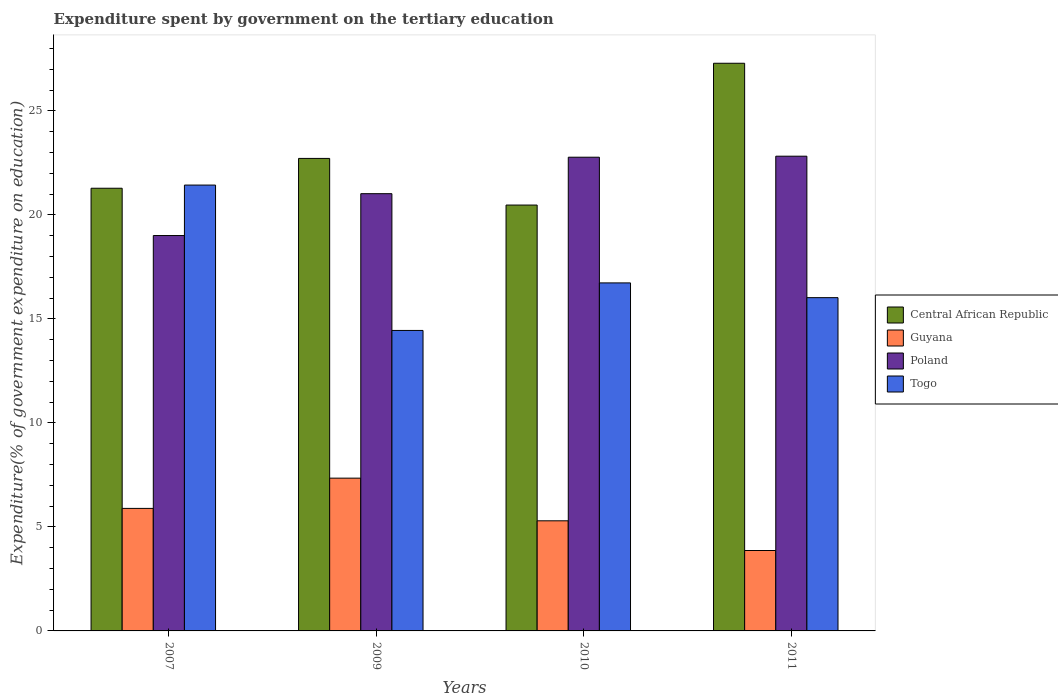Are the number of bars on each tick of the X-axis equal?
Your response must be concise. Yes. What is the label of the 3rd group of bars from the left?
Offer a terse response. 2010. In how many cases, is the number of bars for a given year not equal to the number of legend labels?
Offer a terse response. 0. What is the expenditure spent by government on the tertiary education in Poland in 2007?
Your answer should be compact. 19.01. Across all years, what is the maximum expenditure spent by government on the tertiary education in Guyana?
Your answer should be very brief. 7.34. Across all years, what is the minimum expenditure spent by government on the tertiary education in Poland?
Provide a succinct answer. 19.01. What is the total expenditure spent by government on the tertiary education in Poland in the graph?
Make the answer very short. 85.63. What is the difference between the expenditure spent by government on the tertiary education in Central African Republic in 2007 and that in 2011?
Your response must be concise. -6.01. What is the difference between the expenditure spent by government on the tertiary education in Guyana in 2010 and the expenditure spent by government on the tertiary education in Poland in 2009?
Your answer should be compact. -15.73. What is the average expenditure spent by government on the tertiary education in Togo per year?
Give a very brief answer. 17.16. In the year 2007, what is the difference between the expenditure spent by government on the tertiary education in Poland and expenditure spent by government on the tertiary education in Togo?
Give a very brief answer. -2.43. What is the ratio of the expenditure spent by government on the tertiary education in Poland in 2010 to that in 2011?
Make the answer very short. 1. Is the expenditure spent by government on the tertiary education in Central African Republic in 2009 less than that in 2010?
Provide a succinct answer. No. What is the difference between the highest and the second highest expenditure spent by government on the tertiary education in Poland?
Make the answer very short. 0.05. What is the difference between the highest and the lowest expenditure spent by government on the tertiary education in Togo?
Ensure brevity in your answer.  6.99. What does the 4th bar from the left in 2011 represents?
Keep it short and to the point. Togo. What does the 3rd bar from the right in 2011 represents?
Provide a succinct answer. Guyana. Is it the case that in every year, the sum of the expenditure spent by government on the tertiary education in Togo and expenditure spent by government on the tertiary education in Poland is greater than the expenditure spent by government on the tertiary education in Guyana?
Provide a succinct answer. Yes. How many bars are there?
Offer a terse response. 16. How many years are there in the graph?
Your response must be concise. 4. Are the values on the major ticks of Y-axis written in scientific E-notation?
Ensure brevity in your answer.  No. Does the graph contain any zero values?
Your response must be concise. No. How many legend labels are there?
Provide a short and direct response. 4. How are the legend labels stacked?
Offer a very short reply. Vertical. What is the title of the graph?
Keep it short and to the point. Expenditure spent by government on the tertiary education. What is the label or title of the Y-axis?
Provide a short and direct response. Expenditure(% of government expenditure on education). What is the Expenditure(% of government expenditure on education) of Central African Republic in 2007?
Provide a succinct answer. 21.28. What is the Expenditure(% of government expenditure on education) of Guyana in 2007?
Your response must be concise. 5.89. What is the Expenditure(% of government expenditure on education) of Poland in 2007?
Keep it short and to the point. 19.01. What is the Expenditure(% of government expenditure on education) in Togo in 2007?
Ensure brevity in your answer.  21.43. What is the Expenditure(% of government expenditure on education) in Central African Republic in 2009?
Keep it short and to the point. 22.72. What is the Expenditure(% of government expenditure on education) in Guyana in 2009?
Your answer should be very brief. 7.34. What is the Expenditure(% of government expenditure on education) of Poland in 2009?
Give a very brief answer. 21.02. What is the Expenditure(% of government expenditure on education) of Togo in 2009?
Provide a succinct answer. 14.45. What is the Expenditure(% of government expenditure on education) in Central African Republic in 2010?
Offer a very short reply. 20.47. What is the Expenditure(% of government expenditure on education) in Guyana in 2010?
Provide a short and direct response. 5.29. What is the Expenditure(% of government expenditure on education) in Poland in 2010?
Your answer should be compact. 22.77. What is the Expenditure(% of government expenditure on education) of Togo in 2010?
Offer a very short reply. 16.73. What is the Expenditure(% of government expenditure on education) of Central African Republic in 2011?
Your response must be concise. 27.29. What is the Expenditure(% of government expenditure on education) in Guyana in 2011?
Ensure brevity in your answer.  3.87. What is the Expenditure(% of government expenditure on education) of Poland in 2011?
Your response must be concise. 22.82. What is the Expenditure(% of government expenditure on education) of Togo in 2011?
Offer a terse response. 16.02. Across all years, what is the maximum Expenditure(% of government expenditure on education) of Central African Republic?
Make the answer very short. 27.29. Across all years, what is the maximum Expenditure(% of government expenditure on education) of Guyana?
Offer a very short reply. 7.34. Across all years, what is the maximum Expenditure(% of government expenditure on education) in Poland?
Make the answer very short. 22.82. Across all years, what is the maximum Expenditure(% of government expenditure on education) of Togo?
Provide a short and direct response. 21.43. Across all years, what is the minimum Expenditure(% of government expenditure on education) of Central African Republic?
Your response must be concise. 20.47. Across all years, what is the minimum Expenditure(% of government expenditure on education) of Guyana?
Ensure brevity in your answer.  3.87. Across all years, what is the minimum Expenditure(% of government expenditure on education) of Poland?
Your answer should be very brief. 19.01. Across all years, what is the minimum Expenditure(% of government expenditure on education) in Togo?
Give a very brief answer. 14.45. What is the total Expenditure(% of government expenditure on education) of Central African Republic in the graph?
Make the answer very short. 91.76. What is the total Expenditure(% of government expenditure on education) in Guyana in the graph?
Ensure brevity in your answer.  22.39. What is the total Expenditure(% of government expenditure on education) of Poland in the graph?
Offer a very short reply. 85.63. What is the total Expenditure(% of government expenditure on education) of Togo in the graph?
Keep it short and to the point. 68.63. What is the difference between the Expenditure(% of government expenditure on education) in Central African Republic in 2007 and that in 2009?
Provide a short and direct response. -1.43. What is the difference between the Expenditure(% of government expenditure on education) of Guyana in 2007 and that in 2009?
Offer a very short reply. -1.45. What is the difference between the Expenditure(% of government expenditure on education) of Poland in 2007 and that in 2009?
Offer a very short reply. -2.01. What is the difference between the Expenditure(% of government expenditure on education) in Togo in 2007 and that in 2009?
Provide a succinct answer. 6.99. What is the difference between the Expenditure(% of government expenditure on education) of Central African Republic in 2007 and that in 2010?
Provide a short and direct response. 0.81. What is the difference between the Expenditure(% of government expenditure on education) of Guyana in 2007 and that in 2010?
Your response must be concise. 0.6. What is the difference between the Expenditure(% of government expenditure on education) in Poland in 2007 and that in 2010?
Give a very brief answer. -3.77. What is the difference between the Expenditure(% of government expenditure on education) of Togo in 2007 and that in 2010?
Make the answer very short. 4.7. What is the difference between the Expenditure(% of government expenditure on education) in Central African Republic in 2007 and that in 2011?
Your answer should be compact. -6.01. What is the difference between the Expenditure(% of government expenditure on education) in Guyana in 2007 and that in 2011?
Offer a very short reply. 2.02. What is the difference between the Expenditure(% of government expenditure on education) of Poland in 2007 and that in 2011?
Give a very brief answer. -3.81. What is the difference between the Expenditure(% of government expenditure on education) of Togo in 2007 and that in 2011?
Offer a terse response. 5.41. What is the difference between the Expenditure(% of government expenditure on education) of Central African Republic in 2009 and that in 2010?
Keep it short and to the point. 2.24. What is the difference between the Expenditure(% of government expenditure on education) in Guyana in 2009 and that in 2010?
Provide a short and direct response. 2.05. What is the difference between the Expenditure(% of government expenditure on education) in Poland in 2009 and that in 2010?
Keep it short and to the point. -1.75. What is the difference between the Expenditure(% of government expenditure on education) in Togo in 2009 and that in 2010?
Ensure brevity in your answer.  -2.29. What is the difference between the Expenditure(% of government expenditure on education) of Central African Republic in 2009 and that in 2011?
Keep it short and to the point. -4.58. What is the difference between the Expenditure(% of government expenditure on education) in Guyana in 2009 and that in 2011?
Make the answer very short. 3.48. What is the difference between the Expenditure(% of government expenditure on education) in Poland in 2009 and that in 2011?
Offer a terse response. -1.8. What is the difference between the Expenditure(% of government expenditure on education) of Togo in 2009 and that in 2011?
Ensure brevity in your answer.  -1.58. What is the difference between the Expenditure(% of government expenditure on education) in Central African Republic in 2010 and that in 2011?
Provide a short and direct response. -6.82. What is the difference between the Expenditure(% of government expenditure on education) in Guyana in 2010 and that in 2011?
Give a very brief answer. 1.43. What is the difference between the Expenditure(% of government expenditure on education) of Poland in 2010 and that in 2011?
Ensure brevity in your answer.  -0.05. What is the difference between the Expenditure(% of government expenditure on education) in Togo in 2010 and that in 2011?
Provide a short and direct response. 0.71. What is the difference between the Expenditure(% of government expenditure on education) of Central African Republic in 2007 and the Expenditure(% of government expenditure on education) of Guyana in 2009?
Make the answer very short. 13.94. What is the difference between the Expenditure(% of government expenditure on education) of Central African Republic in 2007 and the Expenditure(% of government expenditure on education) of Poland in 2009?
Your answer should be compact. 0.26. What is the difference between the Expenditure(% of government expenditure on education) in Central African Republic in 2007 and the Expenditure(% of government expenditure on education) in Togo in 2009?
Ensure brevity in your answer.  6.84. What is the difference between the Expenditure(% of government expenditure on education) in Guyana in 2007 and the Expenditure(% of government expenditure on education) in Poland in 2009?
Your response must be concise. -15.13. What is the difference between the Expenditure(% of government expenditure on education) of Guyana in 2007 and the Expenditure(% of government expenditure on education) of Togo in 2009?
Provide a succinct answer. -8.56. What is the difference between the Expenditure(% of government expenditure on education) of Poland in 2007 and the Expenditure(% of government expenditure on education) of Togo in 2009?
Offer a very short reply. 4.56. What is the difference between the Expenditure(% of government expenditure on education) in Central African Republic in 2007 and the Expenditure(% of government expenditure on education) in Guyana in 2010?
Make the answer very short. 15.99. What is the difference between the Expenditure(% of government expenditure on education) of Central African Republic in 2007 and the Expenditure(% of government expenditure on education) of Poland in 2010?
Keep it short and to the point. -1.49. What is the difference between the Expenditure(% of government expenditure on education) of Central African Republic in 2007 and the Expenditure(% of government expenditure on education) of Togo in 2010?
Make the answer very short. 4.55. What is the difference between the Expenditure(% of government expenditure on education) of Guyana in 2007 and the Expenditure(% of government expenditure on education) of Poland in 2010?
Provide a succinct answer. -16.88. What is the difference between the Expenditure(% of government expenditure on education) in Guyana in 2007 and the Expenditure(% of government expenditure on education) in Togo in 2010?
Offer a terse response. -10.84. What is the difference between the Expenditure(% of government expenditure on education) of Poland in 2007 and the Expenditure(% of government expenditure on education) of Togo in 2010?
Offer a very short reply. 2.28. What is the difference between the Expenditure(% of government expenditure on education) in Central African Republic in 2007 and the Expenditure(% of government expenditure on education) in Guyana in 2011?
Keep it short and to the point. 17.42. What is the difference between the Expenditure(% of government expenditure on education) in Central African Republic in 2007 and the Expenditure(% of government expenditure on education) in Poland in 2011?
Provide a succinct answer. -1.54. What is the difference between the Expenditure(% of government expenditure on education) of Central African Republic in 2007 and the Expenditure(% of government expenditure on education) of Togo in 2011?
Your answer should be compact. 5.26. What is the difference between the Expenditure(% of government expenditure on education) of Guyana in 2007 and the Expenditure(% of government expenditure on education) of Poland in 2011?
Provide a short and direct response. -16.93. What is the difference between the Expenditure(% of government expenditure on education) of Guyana in 2007 and the Expenditure(% of government expenditure on education) of Togo in 2011?
Keep it short and to the point. -10.13. What is the difference between the Expenditure(% of government expenditure on education) of Poland in 2007 and the Expenditure(% of government expenditure on education) of Togo in 2011?
Keep it short and to the point. 2.99. What is the difference between the Expenditure(% of government expenditure on education) in Central African Republic in 2009 and the Expenditure(% of government expenditure on education) in Guyana in 2010?
Your answer should be very brief. 17.42. What is the difference between the Expenditure(% of government expenditure on education) in Central African Republic in 2009 and the Expenditure(% of government expenditure on education) in Poland in 2010?
Make the answer very short. -0.06. What is the difference between the Expenditure(% of government expenditure on education) in Central African Republic in 2009 and the Expenditure(% of government expenditure on education) in Togo in 2010?
Make the answer very short. 5.98. What is the difference between the Expenditure(% of government expenditure on education) of Guyana in 2009 and the Expenditure(% of government expenditure on education) of Poland in 2010?
Provide a succinct answer. -15.43. What is the difference between the Expenditure(% of government expenditure on education) of Guyana in 2009 and the Expenditure(% of government expenditure on education) of Togo in 2010?
Offer a very short reply. -9.39. What is the difference between the Expenditure(% of government expenditure on education) in Poland in 2009 and the Expenditure(% of government expenditure on education) in Togo in 2010?
Provide a succinct answer. 4.29. What is the difference between the Expenditure(% of government expenditure on education) in Central African Republic in 2009 and the Expenditure(% of government expenditure on education) in Guyana in 2011?
Give a very brief answer. 18.85. What is the difference between the Expenditure(% of government expenditure on education) in Central African Republic in 2009 and the Expenditure(% of government expenditure on education) in Poland in 2011?
Keep it short and to the point. -0.11. What is the difference between the Expenditure(% of government expenditure on education) of Central African Republic in 2009 and the Expenditure(% of government expenditure on education) of Togo in 2011?
Ensure brevity in your answer.  6.69. What is the difference between the Expenditure(% of government expenditure on education) in Guyana in 2009 and the Expenditure(% of government expenditure on education) in Poland in 2011?
Offer a terse response. -15.48. What is the difference between the Expenditure(% of government expenditure on education) of Guyana in 2009 and the Expenditure(% of government expenditure on education) of Togo in 2011?
Your response must be concise. -8.68. What is the difference between the Expenditure(% of government expenditure on education) of Poland in 2009 and the Expenditure(% of government expenditure on education) of Togo in 2011?
Ensure brevity in your answer.  5. What is the difference between the Expenditure(% of government expenditure on education) in Central African Republic in 2010 and the Expenditure(% of government expenditure on education) in Guyana in 2011?
Give a very brief answer. 16.61. What is the difference between the Expenditure(% of government expenditure on education) of Central African Republic in 2010 and the Expenditure(% of government expenditure on education) of Poland in 2011?
Keep it short and to the point. -2.35. What is the difference between the Expenditure(% of government expenditure on education) of Central African Republic in 2010 and the Expenditure(% of government expenditure on education) of Togo in 2011?
Give a very brief answer. 4.45. What is the difference between the Expenditure(% of government expenditure on education) in Guyana in 2010 and the Expenditure(% of government expenditure on education) in Poland in 2011?
Ensure brevity in your answer.  -17.53. What is the difference between the Expenditure(% of government expenditure on education) in Guyana in 2010 and the Expenditure(% of government expenditure on education) in Togo in 2011?
Provide a short and direct response. -10.73. What is the difference between the Expenditure(% of government expenditure on education) in Poland in 2010 and the Expenditure(% of government expenditure on education) in Togo in 2011?
Keep it short and to the point. 6.75. What is the average Expenditure(% of government expenditure on education) of Central African Republic per year?
Your answer should be very brief. 22.94. What is the average Expenditure(% of government expenditure on education) in Guyana per year?
Your response must be concise. 5.6. What is the average Expenditure(% of government expenditure on education) of Poland per year?
Your answer should be very brief. 21.41. What is the average Expenditure(% of government expenditure on education) in Togo per year?
Your answer should be very brief. 17.16. In the year 2007, what is the difference between the Expenditure(% of government expenditure on education) of Central African Republic and Expenditure(% of government expenditure on education) of Guyana?
Offer a very short reply. 15.39. In the year 2007, what is the difference between the Expenditure(% of government expenditure on education) in Central African Republic and Expenditure(% of government expenditure on education) in Poland?
Offer a terse response. 2.27. In the year 2007, what is the difference between the Expenditure(% of government expenditure on education) in Central African Republic and Expenditure(% of government expenditure on education) in Togo?
Your response must be concise. -0.15. In the year 2007, what is the difference between the Expenditure(% of government expenditure on education) in Guyana and Expenditure(% of government expenditure on education) in Poland?
Provide a short and direct response. -13.12. In the year 2007, what is the difference between the Expenditure(% of government expenditure on education) in Guyana and Expenditure(% of government expenditure on education) in Togo?
Provide a short and direct response. -15.54. In the year 2007, what is the difference between the Expenditure(% of government expenditure on education) in Poland and Expenditure(% of government expenditure on education) in Togo?
Your answer should be very brief. -2.43. In the year 2009, what is the difference between the Expenditure(% of government expenditure on education) in Central African Republic and Expenditure(% of government expenditure on education) in Guyana?
Give a very brief answer. 15.37. In the year 2009, what is the difference between the Expenditure(% of government expenditure on education) in Central African Republic and Expenditure(% of government expenditure on education) in Poland?
Offer a very short reply. 1.7. In the year 2009, what is the difference between the Expenditure(% of government expenditure on education) of Central African Republic and Expenditure(% of government expenditure on education) of Togo?
Provide a short and direct response. 8.27. In the year 2009, what is the difference between the Expenditure(% of government expenditure on education) in Guyana and Expenditure(% of government expenditure on education) in Poland?
Provide a succinct answer. -13.68. In the year 2009, what is the difference between the Expenditure(% of government expenditure on education) of Guyana and Expenditure(% of government expenditure on education) of Togo?
Ensure brevity in your answer.  -7.1. In the year 2009, what is the difference between the Expenditure(% of government expenditure on education) in Poland and Expenditure(% of government expenditure on education) in Togo?
Keep it short and to the point. 6.57. In the year 2010, what is the difference between the Expenditure(% of government expenditure on education) of Central African Republic and Expenditure(% of government expenditure on education) of Guyana?
Offer a very short reply. 15.18. In the year 2010, what is the difference between the Expenditure(% of government expenditure on education) in Central African Republic and Expenditure(% of government expenditure on education) in Poland?
Your answer should be very brief. -2.3. In the year 2010, what is the difference between the Expenditure(% of government expenditure on education) of Central African Republic and Expenditure(% of government expenditure on education) of Togo?
Your response must be concise. 3.74. In the year 2010, what is the difference between the Expenditure(% of government expenditure on education) in Guyana and Expenditure(% of government expenditure on education) in Poland?
Provide a succinct answer. -17.48. In the year 2010, what is the difference between the Expenditure(% of government expenditure on education) in Guyana and Expenditure(% of government expenditure on education) in Togo?
Offer a very short reply. -11.44. In the year 2010, what is the difference between the Expenditure(% of government expenditure on education) in Poland and Expenditure(% of government expenditure on education) in Togo?
Offer a terse response. 6.04. In the year 2011, what is the difference between the Expenditure(% of government expenditure on education) of Central African Republic and Expenditure(% of government expenditure on education) of Guyana?
Keep it short and to the point. 23.43. In the year 2011, what is the difference between the Expenditure(% of government expenditure on education) of Central African Republic and Expenditure(% of government expenditure on education) of Poland?
Your answer should be very brief. 4.47. In the year 2011, what is the difference between the Expenditure(% of government expenditure on education) of Central African Republic and Expenditure(% of government expenditure on education) of Togo?
Your answer should be very brief. 11.27. In the year 2011, what is the difference between the Expenditure(% of government expenditure on education) of Guyana and Expenditure(% of government expenditure on education) of Poland?
Make the answer very short. -18.96. In the year 2011, what is the difference between the Expenditure(% of government expenditure on education) in Guyana and Expenditure(% of government expenditure on education) in Togo?
Your response must be concise. -12.16. In the year 2011, what is the difference between the Expenditure(% of government expenditure on education) of Poland and Expenditure(% of government expenditure on education) of Togo?
Provide a short and direct response. 6.8. What is the ratio of the Expenditure(% of government expenditure on education) of Central African Republic in 2007 to that in 2009?
Offer a terse response. 0.94. What is the ratio of the Expenditure(% of government expenditure on education) of Guyana in 2007 to that in 2009?
Your answer should be compact. 0.8. What is the ratio of the Expenditure(% of government expenditure on education) in Poland in 2007 to that in 2009?
Make the answer very short. 0.9. What is the ratio of the Expenditure(% of government expenditure on education) of Togo in 2007 to that in 2009?
Offer a very short reply. 1.48. What is the ratio of the Expenditure(% of government expenditure on education) in Central African Republic in 2007 to that in 2010?
Provide a succinct answer. 1.04. What is the ratio of the Expenditure(% of government expenditure on education) of Guyana in 2007 to that in 2010?
Provide a short and direct response. 1.11. What is the ratio of the Expenditure(% of government expenditure on education) in Poland in 2007 to that in 2010?
Offer a terse response. 0.83. What is the ratio of the Expenditure(% of government expenditure on education) of Togo in 2007 to that in 2010?
Provide a succinct answer. 1.28. What is the ratio of the Expenditure(% of government expenditure on education) of Central African Republic in 2007 to that in 2011?
Make the answer very short. 0.78. What is the ratio of the Expenditure(% of government expenditure on education) in Guyana in 2007 to that in 2011?
Ensure brevity in your answer.  1.52. What is the ratio of the Expenditure(% of government expenditure on education) in Poland in 2007 to that in 2011?
Offer a terse response. 0.83. What is the ratio of the Expenditure(% of government expenditure on education) in Togo in 2007 to that in 2011?
Your answer should be very brief. 1.34. What is the ratio of the Expenditure(% of government expenditure on education) in Central African Republic in 2009 to that in 2010?
Give a very brief answer. 1.11. What is the ratio of the Expenditure(% of government expenditure on education) of Guyana in 2009 to that in 2010?
Ensure brevity in your answer.  1.39. What is the ratio of the Expenditure(% of government expenditure on education) in Poland in 2009 to that in 2010?
Provide a short and direct response. 0.92. What is the ratio of the Expenditure(% of government expenditure on education) of Togo in 2009 to that in 2010?
Ensure brevity in your answer.  0.86. What is the ratio of the Expenditure(% of government expenditure on education) in Central African Republic in 2009 to that in 2011?
Offer a terse response. 0.83. What is the ratio of the Expenditure(% of government expenditure on education) in Guyana in 2009 to that in 2011?
Offer a terse response. 1.9. What is the ratio of the Expenditure(% of government expenditure on education) in Poland in 2009 to that in 2011?
Ensure brevity in your answer.  0.92. What is the ratio of the Expenditure(% of government expenditure on education) in Togo in 2009 to that in 2011?
Your response must be concise. 0.9. What is the ratio of the Expenditure(% of government expenditure on education) in Central African Republic in 2010 to that in 2011?
Make the answer very short. 0.75. What is the ratio of the Expenditure(% of government expenditure on education) of Guyana in 2010 to that in 2011?
Your answer should be compact. 1.37. What is the ratio of the Expenditure(% of government expenditure on education) in Togo in 2010 to that in 2011?
Offer a terse response. 1.04. What is the difference between the highest and the second highest Expenditure(% of government expenditure on education) in Central African Republic?
Keep it short and to the point. 4.58. What is the difference between the highest and the second highest Expenditure(% of government expenditure on education) in Guyana?
Keep it short and to the point. 1.45. What is the difference between the highest and the second highest Expenditure(% of government expenditure on education) of Poland?
Provide a succinct answer. 0.05. What is the difference between the highest and the second highest Expenditure(% of government expenditure on education) of Togo?
Your response must be concise. 4.7. What is the difference between the highest and the lowest Expenditure(% of government expenditure on education) in Central African Republic?
Your answer should be very brief. 6.82. What is the difference between the highest and the lowest Expenditure(% of government expenditure on education) in Guyana?
Provide a short and direct response. 3.48. What is the difference between the highest and the lowest Expenditure(% of government expenditure on education) in Poland?
Offer a terse response. 3.81. What is the difference between the highest and the lowest Expenditure(% of government expenditure on education) of Togo?
Your answer should be compact. 6.99. 